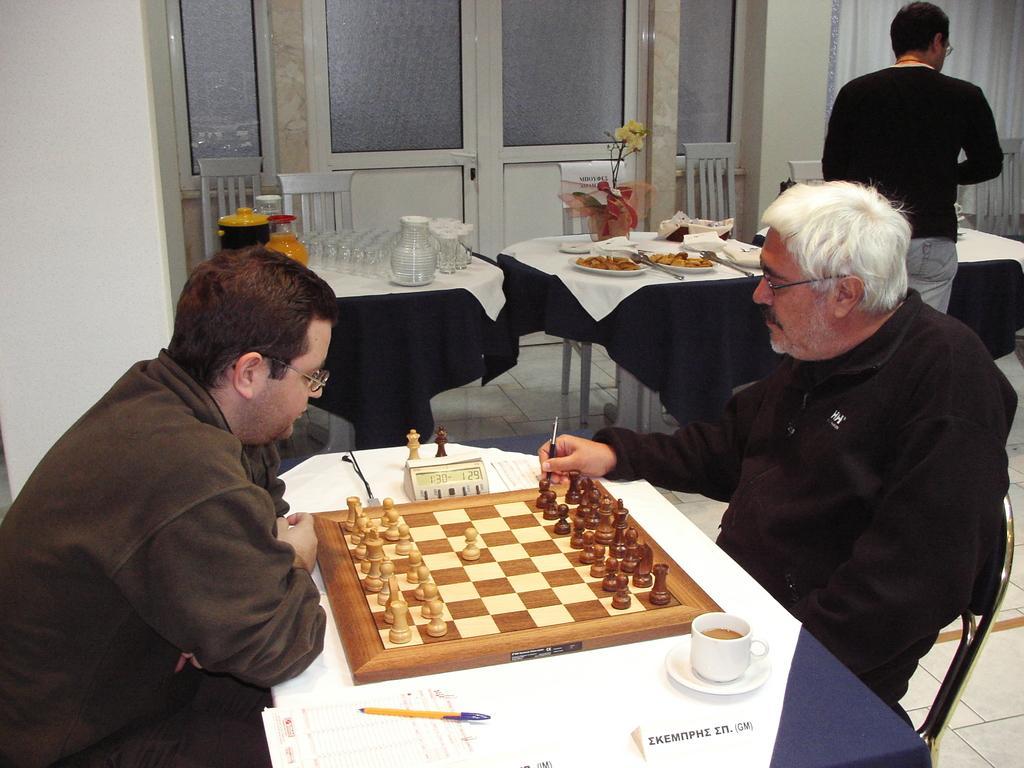Please provide a concise description of this image. In this image I can see two person sitting on the chair. On the table there chess board,cup,saucers,pen and there is food. 